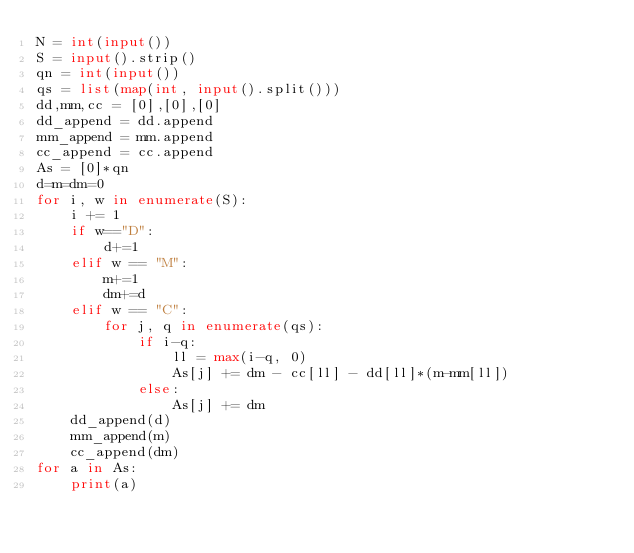<code> <loc_0><loc_0><loc_500><loc_500><_Python_>N = int(input())
S = input().strip()
qn = int(input())
qs = list(map(int, input().split()))
dd,mm,cc = [0],[0],[0]
dd_append = dd.append
mm_append = mm.append
cc_append = cc.append
As = [0]*qn
d=m=dm=0
for i, w in enumerate(S):
    i += 1
    if w=="D":
        d+=1
    elif w == "M":
        m+=1
        dm+=d
    elif w == "C":
        for j, q in enumerate(qs):
            if i-q:
                ll = max(i-q, 0)
                As[j] += dm - cc[ll] - dd[ll]*(m-mm[ll])
            else:
                As[j] += dm
    dd_append(d)
    mm_append(m)
    cc_append(dm)
for a in As:
    print(a)
</code> 